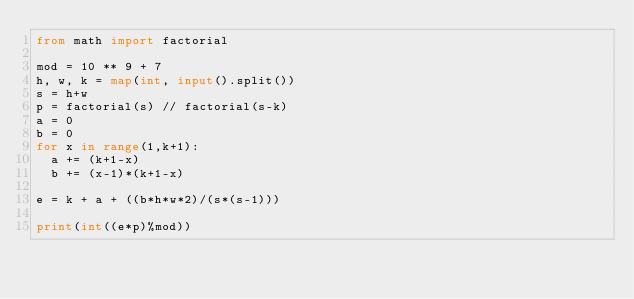<code> <loc_0><loc_0><loc_500><loc_500><_Python_>from math import factorial

mod = 10 ** 9 + 7
h, w, k = map(int, input().split())
s = h+w
p = factorial(s) // factorial(s-k)
a = 0
b = 0
for x in range(1,k+1):
  a += (k+1-x)
  b += (x-1)*(k+1-x)

e = k + a + ((b*h*w*2)/(s*(s-1)))

print(int((e*p)%mod))</code> 